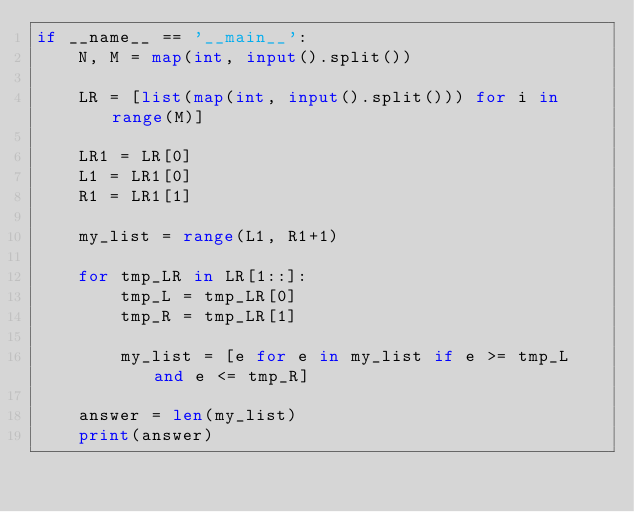Convert code to text. <code><loc_0><loc_0><loc_500><loc_500><_Python_>if __name__ == '__main__':
    N, M = map(int, input().split())

    LR = [list(map(int, input().split())) for i in range(M)]

    LR1 = LR[0]
    L1 = LR1[0]
    R1 = LR1[1]

    my_list = range(L1, R1+1)

    for tmp_LR in LR[1::]:
        tmp_L = tmp_LR[0]
        tmp_R = tmp_LR[1]

        my_list = [e for e in my_list if e >= tmp_L and e <= tmp_R]

    answer = len(my_list)
    print(answer)
</code> 